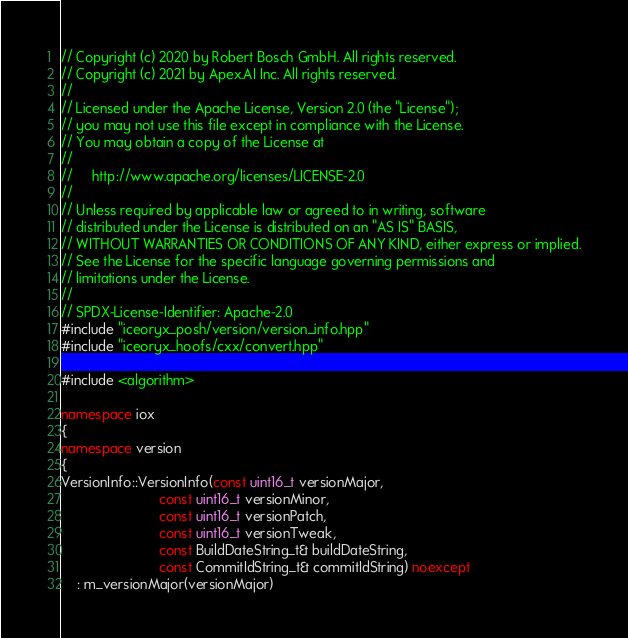<code> <loc_0><loc_0><loc_500><loc_500><_C++_>// Copyright (c) 2020 by Robert Bosch GmbH. All rights reserved.
// Copyright (c) 2021 by Apex.AI Inc. All rights reserved.
//
// Licensed under the Apache License, Version 2.0 (the "License");
// you may not use this file except in compliance with the License.
// You may obtain a copy of the License at
//
//     http://www.apache.org/licenses/LICENSE-2.0
//
// Unless required by applicable law or agreed to in writing, software
// distributed under the License is distributed on an "AS IS" BASIS,
// WITHOUT WARRANTIES OR CONDITIONS OF ANY KIND, either express or implied.
// See the License for the specific language governing permissions and
// limitations under the License.
//
// SPDX-License-Identifier: Apache-2.0
#include "iceoryx_posh/version/version_info.hpp"
#include "iceoryx_hoofs/cxx/convert.hpp"

#include <algorithm>

namespace iox
{
namespace version
{
VersionInfo::VersionInfo(const uint16_t versionMajor,
                         const uint16_t versionMinor,
                         const uint16_t versionPatch,
                         const uint16_t versionTweak,
                         const BuildDateString_t& buildDateString,
                         const CommitIdString_t& commitIdString) noexcept
    : m_versionMajor(versionMajor)</code> 